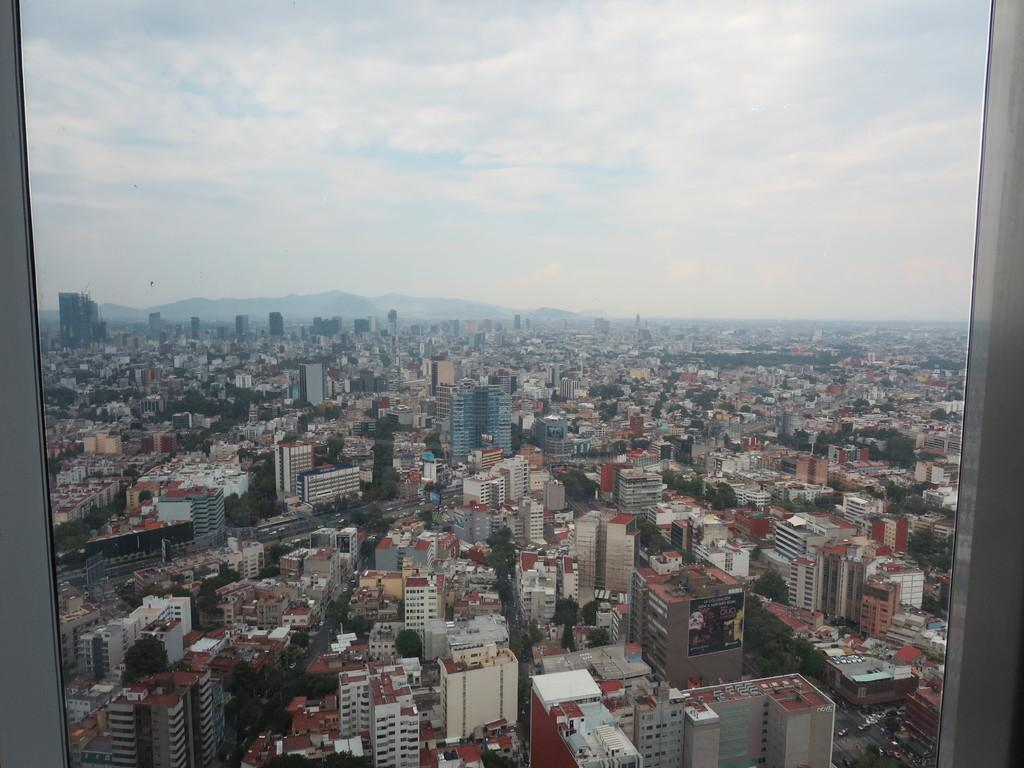What is in the glass that is visible in the image? The glass contains a representation of buildings, roads, vehicles, trees, and mountains. What can be seen in the sky at the top of the image? The sky is visible at the top of the image. How many jellyfish are swimming in the glass in the image? There are no jellyfish present in the image; the glass contains representations of buildings, roads, vehicles, trees, and mountains. 